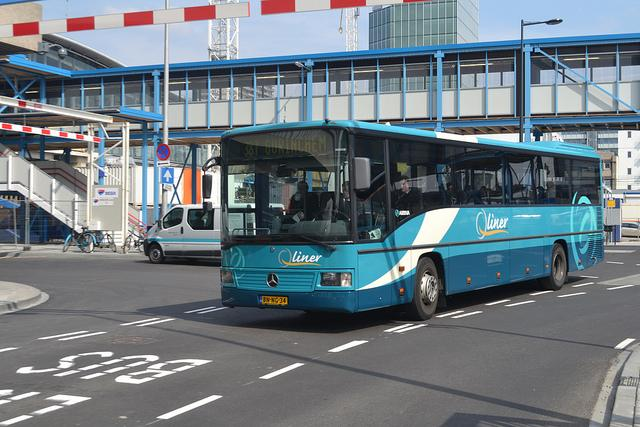What word is on the ground in white letters? Please explain your reasoning. bus. The word on the ground is bus. 